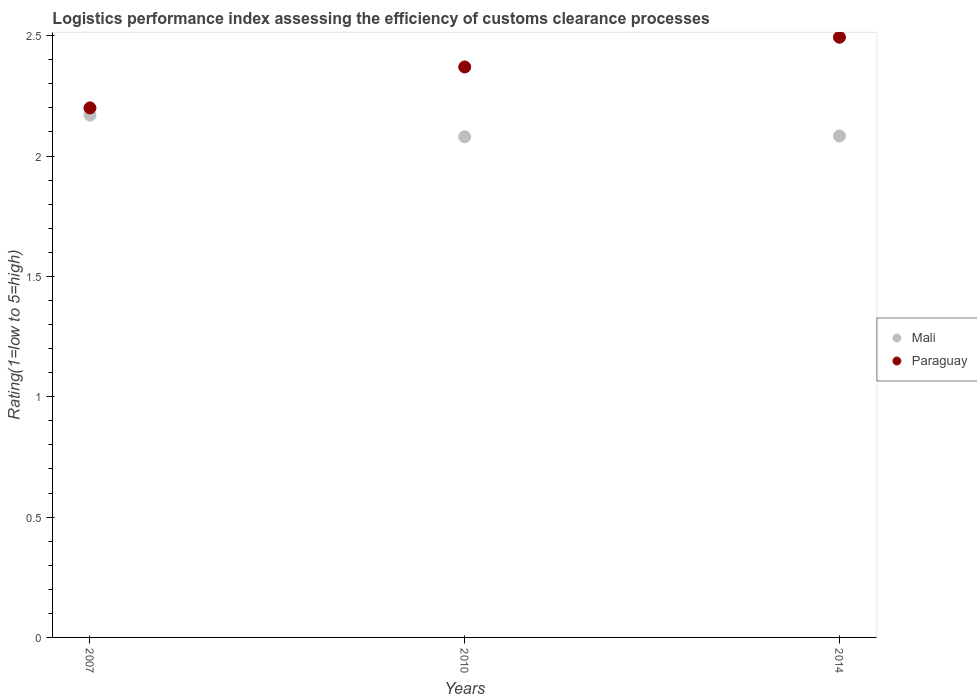How many different coloured dotlines are there?
Keep it short and to the point. 2. What is the Logistic performance index in Mali in 2014?
Offer a terse response. 2.08. Across all years, what is the maximum Logistic performance index in Mali?
Your answer should be very brief. 2.17. In which year was the Logistic performance index in Paraguay minimum?
Offer a terse response. 2007. What is the total Logistic performance index in Paraguay in the graph?
Give a very brief answer. 7.06. What is the difference between the Logistic performance index in Paraguay in 2007 and that in 2010?
Offer a terse response. -0.17. What is the difference between the Logistic performance index in Paraguay in 2014 and the Logistic performance index in Mali in 2010?
Make the answer very short. 0.41. What is the average Logistic performance index in Paraguay per year?
Make the answer very short. 2.35. In the year 2007, what is the difference between the Logistic performance index in Paraguay and Logistic performance index in Mali?
Give a very brief answer. 0.03. In how many years, is the Logistic performance index in Paraguay greater than 2.4?
Provide a short and direct response. 1. What is the ratio of the Logistic performance index in Paraguay in 2007 to that in 2010?
Your answer should be very brief. 0.93. What is the difference between the highest and the second highest Logistic performance index in Mali?
Offer a terse response. 0.09. What is the difference between the highest and the lowest Logistic performance index in Mali?
Offer a very short reply. 0.09. In how many years, is the Logistic performance index in Mali greater than the average Logistic performance index in Mali taken over all years?
Provide a short and direct response. 1. Does the Logistic performance index in Mali monotonically increase over the years?
Provide a short and direct response. No. How many years are there in the graph?
Your response must be concise. 3. What is the difference between two consecutive major ticks on the Y-axis?
Your answer should be very brief. 0.5. Does the graph contain any zero values?
Keep it short and to the point. No. Does the graph contain grids?
Ensure brevity in your answer.  No. Where does the legend appear in the graph?
Your response must be concise. Center right. What is the title of the graph?
Make the answer very short. Logistics performance index assessing the efficiency of customs clearance processes. Does "Uzbekistan" appear as one of the legend labels in the graph?
Offer a terse response. No. What is the label or title of the X-axis?
Your answer should be compact. Years. What is the label or title of the Y-axis?
Keep it short and to the point. Rating(1=low to 5=high). What is the Rating(1=low to 5=high) in Mali in 2007?
Your response must be concise. 2.17. What is the Rating(1=low to 5=high) of Paraguay in 2007?
Ensure brevity in your answer.  2.2. What is the Rating(1=low to 5=high) of Mali in 2010?
Offer a terse response. 2.08. What is the Rating(1=low to 5=high) in Paraguay in 2010?
Provide a short and direct response. 2.37. What is the Rating(1=low to 5=high) in Mali in 2014?
Give a very brief answer. 2.08. What is the Rating(1=low to 5=high) in Paraguay in 2014?
Ensure brevity in your answer.  2.49. Across all years, what is the maximum Rating(1=low to 5=high) in Mali?
Offer a terse response. 2.17. Across all years, what is the maximum Rating(1=low to 5=high) in Paraguay?
Your response must be concise. 2.49. Across all years, what is the minimum Rating(1=low to 5=high) of Mali?
Provide a short and direct response. 2.08. What is the total Rating(1=low to 5=high) in Mali in the graph?
Provide a short and direct response. 6.33. What is the total Rating(1=low to 5=high) in Paraguay in the graph?
Provide a short and direct response. 7.06. What is the difference between the Rating(1=low to 5=high) of Mali in 2007 and that in 2010?
Your answer should be compact. 0.09. What is the difference between the Rating(1=low to 5=high) in Paraguay in 2007 and that in 2010?
Your response must be concise. -0.17. What is the difference between the Rating(1=low to 5=high) of Mali in 2007 and that in 2014?
Offer a very short reply. 0.09. What is the difference between the Rating(1=low to 5=high) in Paraguay in 2007 and that in 2014?
Provide a short and direct response. -0.29. What is the difference between the Rating(1=low to 5=high) in Mali in 2010 and that in 2014?
Your answer should be compact. -0. What is the difference between the Rating(1=low to 5=high) in Paraguay in 2010 and that in 2014?
Your answer should be compact. -0.12. What is the difference between the Rating(1=low to 5=high) of Mali in 2007 and the Rating(1=low to 5=high) of Paraguay in 2010?
Offer a very short reply. -0.2. What is the difference between the Rating(1=low to 5=high) of Mali in 2007 and the Rating(1=low to 5=high) of Paraguay in 2014?
Provide a short and direct response. -0.32. What is the difference between the Rating(1=low to 5=high) of Mali in 2010 and the Rating(1=low to 5=high) of Paraguay in 2014?
Provide a short and direct response. -0.41. What is the average Rating(1=low to 5=high) in Mali per year?
Ensure brevity in your answer.  2.11. What is the average Rating(1=low to 5=high) of Paraguay per year?
Ensure brevity in your answer.  2.35. In the year 2007, what is the difference between the Rating(1=low to 5=high) in Mali and Rating(1=low to 5=high) in Paraguay?
Give a very brief answer. -0.03. In the year 2010, what is the difference between the Rating(1=low to 5=high) in Mali and Rating(1=low to 5=high) in Paraguay?
Your answer should be very brief. -0.29. In the year 2014, what is the difference between the Rating(1=low to 5=high) in Mali and Rating(1=low to 5=high) in Paraguay?
Give a very brief answer. -0.41. What is the ratio of the Rating(1=low to 5=high) of Mali in 2007 to that in 2010?
Your response must be concise. 1.04. What is the ratio of the Rating(1=low to 5=high) of Paraguay in 2007 to that in 2010?
Your response must be concise. 0.93. What is the ratio of the Rating(1=low to 5=high) in Mali in 2007 to that in 2014?
Your response must be concise. 1.04. What is the ratio of the Rating(1=low to 5=high) in Paraguay in 2007 to that in 2014?
Give a very brief answer. 0.88. What is the ratio of the Rating(1=low to 5=high) in Mali in 2010 to that in 2014?
Provide a succinct answer. 1. What is the ratio of the Rating(1=low to 5=high) of Paraguay in 2010 to that in 2014?
Ensure brevity in your answer.  0.95. What is the difference between the highest and the second highest Rating(1=low to 5=high) of Mali?
Offer a very short reply. 0.09. What is the difference between the highest and the second highest Rating(1=low to 5=high) in Paraguay?
Ensure brevity in your answer.  0.12. What is the difference between the highest and the lowest Rating(1=low to 5=high) of Mali?
Your answer should be compact. 0.09. What is the difference between the highest and the lowest Rating(1=low to 5=high) in Paraguay?
Make the answer very short. 0.29. 